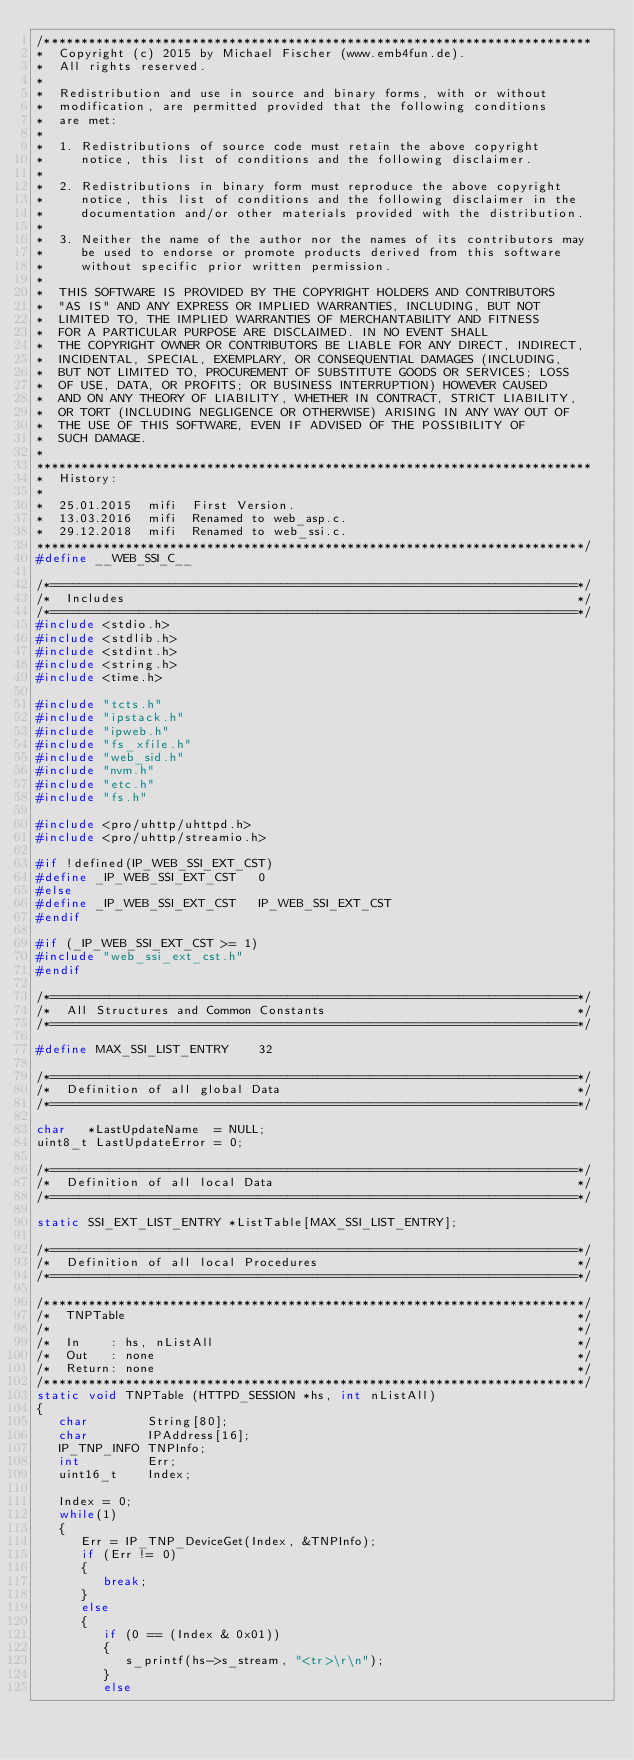Convert code to text. <code><loc_0><loc_0><loc_500><loc_500><_C_>/**************************************************************************
*  Copyright (c) 2015 by Michael Fischer (www.emb4fun.de).
*  All rights reserved.
*
*  Redistribution and use in source and binary forms, with or without 
*  modification, are permitted provided that the following conditions 
*  are met:
*  
*  1. Redistributions of source code must retain the above copyright 
*     notice, this list of conditions and the following disclaimer.
*
*  2. Redistributions in binary form must reproduce the above copyright
*     notice, this list of conditions and the following disclaimer in the 
*     documentation and/or other materials provided with the distribution.
*
*  3. Neither the name of the author nor the names of its contributors may 
*     be used to endorse or promote products derived from this software 
*     without specific prior written permission.
*
*  THIS SOFTWARE IS PROVIDED BY THE COPYRIGHT HOLDERS AND CONTRIBUTORS 
*  "AS IS" AND ANY EXPRESS OR IMPLIED WARRANTIES, INCLUDING, BUT NOT 
*  LIMITED TO, THE IMPLIED WARRANTIES OF MERCHANTABILITY AND FITNESS 
*  FOR A PARTICULAR PURPOSE ARE DISCLAIMED. IN NO EVENT SHALL 
*  THE COPYRIGHT OWNER OR CONTRIBUTORS BE LIABLE FOR ANY DIRECT, INDIRECT, 
*  INCIDENTAL, SPECIAL, EXEMPLARY, OR CONSEQUENTIAL DAMAGES (INCLUDING, 
*  BUT NOT LIMITED TO, PROCUREMENT OF SUBSTITUTE GOODS OR SERVICES; LOSS 
*  OF USE, DATA, OR PROFITS; OR BUSINESS INTERRUPTION) HOWEVER CAUSED 
*  AND ON ANY THEORY OF LIABILITY, WHETHER IN CONTRACT, STRICT LIABILITY, 
*  OR TORT (INCLUDING NEGLIGENCE OR OTHERWISE) ARISING IN ANY WAY OUT OF 
*  THE USE OF THIS SOFTWARE, EVEN IF ADVISED OF THE POSSIBILITY OF 
*  SUCH DAMAGE.
*
***************************************************************************
*  History:
*
*  25.01.2015  mifi  First Version.
*  13.03.2016  mifi  Renamed to web_asp.c.
*  29.12.2018  mifi  Renamed to web_ssi.c.
**************************************************************************/
#define __WEB_SSI_C__

/*=======================================================================*/
/*  Includes                                                             */
/*=======================================================================*/
#include <stdio.h>
#include <stdlib.h>
#include <stdint.h>
#include <string.h>
#include <time.h>

#include "tcts.h"
#include "ipstack.h"
#include "ipweb.h"
#include "fs_xfile.h"
#include "web_sid.h"
#include "nvm.h"
#include "etc.h"
#include "fs.h"

#include <pro/uhttp/uhttpd.h>
#include <pro/uhttp/streamio.h>

#if !defined(IP_WEB_SSI_EXT_CST) 
#define _IP_WEB_SSI_EXT_CST   0
#else
#define _IP_WEB_SSI_EXT_CST   IP_WEB_SSI_EXT_CST
#endif  

#if (_IP_WEB_SSI_EXT_CST >= 1)
#include "web_ssi_ext_cst.h"
#endif

/*=======================================================================*/
/*  All Structures and Common Constants                                  */
/*=======================================================================*/

#define MAX_SSI_LIST_ENTRY    32

/*=======================================================================*/
/*  Definition of all global Data                                        */
/*=======================================================================*/

char   *LastUpdateName  = NULL;
uint8_t LastUpdateError = 0;

/*=======================================================================*/
/*  Definition of all local Data                                         */
/*=======================================================================*/

static SSI_EXT_LIST_ENTRY *ListTable[MAX_SSI_LIST_ENTRY];

/*=======================================================================*/
/*  Definition of all local Procedures                                   */
/*=======================================================================*/

/*************************************************************************/
/*  TNPTable                                                             */
/*                                                                       */
/*  In    : hs, nListAll                                                 */
/*  Out   : none                                                         */
/*  Return: none                                                         */
/*************************************************************************/
static void TNPTable (HTTPD_SESSION *hs, int nListAll)
{
   char        String[80];
   char        IPAddress[16];
   IP_TNP_INFO TNPInfo;
   int         Err;
   uint16_t    Index;

   Index = 0;   
   while(1)
   {
      Err = IP_TNP_DeviceGet(Index, &TNPInfo);
      if (Err != 0)
      {
         break;
      }
      else
      {      
         if (0 == (Index & 0x01))
         {
            s_printf(hs->s_stream, "<tr>\r\n");
         }
         else</code> 